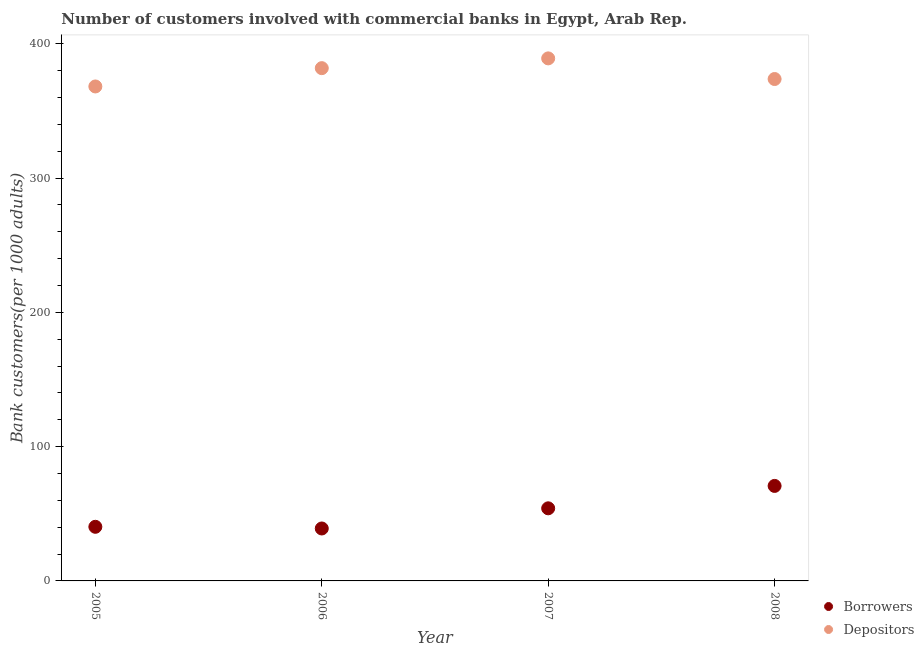How many different coloured dotlines are there?
Ensure brevity in your answer.  2. Is the number of dotlines equal to the number of legend labels?
Ensure brevity in your answer.  Yes. What is the number of borrowers in 2007?
Keep it short and to the point. 54.06. Across all years, what is the maximum number of borrowers?
Give a very brief answer. 70.74. Across all years, what is the minimum number of depositors?
Offer a very short reply. 368.19. In which year was the number of depositors maximum?
Keep it short and to the point. 2007. In which year was the number of depositors minimum?
Give a very brief answer. 2005. What is the total number of depositors in the graph?
Make the answer very short. 1512.86. What is the difference between the number of depositors in 2006 and that in 2008?
Give a very brief answer. 8.09. What is the difference between the number of depositors in 2006 and the number of borrowers in 2008?
Make the answer very short. 311.08. What is the average number of depositors per year?
Offer a terse response. 378.22. In the year 2006, what is the difference between the number of depositors and number of borrowers?
Offer a very short reply. 342.78. What is the ratio of the number of depositors in 2007 to that in 2008?
Provide a short and direct response. 1.04. Is the number of depositors in 2005 less than that in 2006?
Provide a short and direct response. Yes. Is the difference between the number of borrowers in 2005 and 2006 greater than the difference between the number of depositors in 2005 and 2006?
Your answer should be very brief. Yes. What is the difference between the highest and the second highest number of borrowers?
Your answer should be compact. 16.68. What is the difference between the highest and the lowest number of depositors?
Provide a short and direct response. 20.91. In how many years, is the number of depositors greater than the average number of depositors taken over all years?
Your response must be concise. 2. Is the sum of the number of borrowers in 2005 and 2006 greater than the maximum number of depositors across all years?
Your response must be concise. No. How many dotlines are there?
Keep it short and to the point. 2. What is the difference between two consecutive major ticks on the Y-axis?
Provide a short and direct response. 100. Are the values on the major ticks of Y-axis written in scientific E-notation?
Ensure brevity in your answer.  No. Does the graph contain grids?
Your response must be concise. No. What is the title of the graph?
Make the answer very short. Number of customers involved with commercial banks in Egypt, Arab Rep. Does "Frequency of shipment arrival" appear as one of the legend labels in the graph?
Provide a short and direct response. No. What is the label or title of the X-axis?
Your response must be concise. Year. What is the label or title of the Y-axis?
Your response must be concise. Bank customers(per 1000 adults). What is the Bank customers(per 1000 adults) in Borrowers in 2005?
Make the answer very short. 40.3. What is the Bank customers(per 1000 adults) in Depositors in 2005?
Your response must be concise. 368.19. What is the Bank customers(per 1000 adults) of Borrowers in 2006?
Ensure brevity in your answer.  39.05. What is the Bank customers(per 1000 adults) of Depositors in 2006?
Provide a short and direct response. 381.83. What is the Bank customers(per 1000 adults) of Borrowers in 2007?
Offer a very short reply. 54.06. What is the Bank customers(per 1000 adults) in Depositors in 2007?
Your response must be concise. 389.11. What is the Bank customers(per 1000 adults) in Borrowers in 2008?
Give a very brief answer. 70.74. What is the Bank customers(per 1000 adults) in Depositors in 2008?
Offer a terse response. 373.74. Across all years, what is the maximum Bank customers(per 1000 adults) of Borrowers?
Your response must be concise. 70.74. Across all years, what is the maximum Bank customers(per 1000 adults) of Depositors?
Your answer should be very brief. 389.11. Across all years, what is the minimum Bank customers(per 1000 adults) of Borrowers?
Your answer should be very brief. 39.05. Across all years, what is the minimum Bank customers(per 1000 adults) of Depositors?
Your response must be concise. 368.19. What is the total Bank customers(per 1000 adults) of Borrowers in the graph?
Keep it short and to the point. 204.15. What is the total Bank customers(per 1000 adults) in Depositors in the graph?
Offer a very short reply. 1512.86. What is the difference between the Bank customers(per 1000 adults) in Borrowers in 2005 and that in 2006?
Offer a terse response. 1.25. What is the difference between the Bank customers(per 1000 adults) in Depositors in 2005 and that in 2006?
Provide a succinct answer. -13.63. What is the difference between the Bank customers(per 1000 adults) of Borrowers in 2005 and that in 2007?
Your answer should be very brief. -13.77. What is the difference between the Bank customers(per 1000 adults) in Depositors in 2005 and that in 2007?
Make the answer very short. -20.91. What is the difference between the Bank customers(per 1000 adults) of Borrowers in 2005 and that in 2008?
Give a very brief answer. -30.45. What is the difference between the Bank customers(per 1000 adults) of Depositors in 2005 and that in 2008?
Give a very brief answer. -5.54. What is the difference between the Bank customers(per 1000 adults) in Borrowers in 2006 and that in 2007?
Keep it short and to the point. -15.02. What is the difference between the Bank customers(per 1000 adults) in Depositors in 2006 and that in 2007?
Give a very brief answer. -7.28. What is the difference between the Bank customers(per 1000 adults) of Borrowers in 2006 and that in 2008?
Provide a short and direct response. -31.69. What is the difference between the Bank customers(per 1000 adults) in Depositors in 2006 and that in 2008?
Ensure brevity in your answer.  8.09. What is the difference between the Bank customers(per 1000 adults) of Borrowers in 2007 and that in 2008?
Keep it short and to the point. -16.68. What is the difference between the Bank customers(per 1000 adults) of Depositors in 2007 and that in 2008?
Offer a terse response. 15.37. What is the difference between the Bank customers(per 1000 adults) in Borrowers in 2005 and the Bank customers(per 1000 adults) in Depositors in 2006?
Keep it short and to the point. -341.53. What is the difference between the Bank customers(per 1000 adults) in Borrowers in 2005 and the Bank customers(per 1000 adults) in Depositors in 2007?
Keep it short and to the point. -348.81. What is the difference between the Bank customers(per 1000 adults) in Borrowers in 2005 and the Bank customers(per 1000 adults) in Depositors in 2008?
Your answer should be compact. -333.44. What is the difference between the Bank customers(per 1000 adults) of Borrowers in 2006 and the Bank customers(per 1000 adults) of Depositors in 2007?
Provide a short and direct response. -350.06. What is the difference between the Bank customers(per 1000 adults) of Borrowers in 2006 and the Bank customers(per 1000 adults) of Depositors in 2008?
Your answer should be very brief. -334.69. What is the difference between the Bank customers(per 1000 adults) of Borrowers in 2007 and the Bank customers(per 1000 adults) of Depositors in 2008?
Ensure brevity in your answer.  -319.67. What is the average Bank customers(per 1000 adults) of Borrowers per year?
Give a very brief answer. 51.04. What is the average Bank customers(per 1000 adults) of Depositors per year?
Your answer should be compact. 378.22. In the year 2005, what is the difference between the Bank customers(per 1000 adults) in Borrowers and Bank customers(per 1000 adults) in Depositors?
Your answer should be very brief. -327.9. In the year 2006, what is the difference between the Bank customers(per 1000 adults) of Borrowers and Bank customers(per 1000 adults) of Depositors?
Offer a very short reply. -342.78. In the year 2007, what is the difference between the Bank customers(per 1000 adults) of Borrowers and Bank customers(per 1000 adults) of Depositors?
Provide a short and direct response. -335.04. In the year 2008, what is the difference between the Bank customers(per 1000 adults) of Borrowers and Bank customers(per 1000 adults) of Depositors?
Your answer should be compact. -302.99. What is the ratio of the Bank customers(per 1000 adults) of Borrowers in 2005 to that in 2006?
Offer a terse response. 1.03. What is the ratio of the Bank customers(per 1000 adults) in Depositors in 2005 to that in 2006?
Your answer should be very brief. 0.96. What is the ratio of the Bank customers(per 1000 adults) in Borrowers in 2005 to that in 2007?
Provide a short and direct response. 0.75. What is the ratio of the Bank customers(per 1000 adults) in Depositors in 2005 to that in 2007?
Your answer should be compact. 0.95. What is the ratio of the Bank customers(per 1000 adults) in Borrowers in 2005 to that in 2008?
Provide a succinct answer. 0.57. What is the ratio of the Bank customers(per 1000 adults) in Depositors in 2005 to that in 2008?
Offer a terse response. 0.99. What is the ratio of the Bank customers(per 1000 adults) in Borrowers in 2006 to that in 2007?
Keep it short and to the point. 0.72. What is the ratio of the Bank customers(per 1000 adults) of Depositors in 2006 to that in 2007?
Ensure brevity in your answer.  0.98. What is the ratio of the Bank customers(per 1000 adults) in Borrowers in 2006 to that in 2008?
Make the answer very short. 0.55. What is the ratio of the Bank customers(per 1000 adults) in Depositors in 2006 to that in 2008?
Make the answer very short. 1.02. What is the ratio of the Bank customers(per 1000 adults) in Borrowers in 2007 to that in 2008?
Keep it short and to the point. 0.76. What is the ratio of the Bank customers(per 1000 adults) of Depositors in 2007 to that in 2008?
Give a very brief answer. 1.04. What is the difference between the highest and the second highest Bank customers(per 1000 adults) in Borrowers?
Provide a short and direct response. 16.68. What is the difference between the highest and the second highest Bank customers(per 1000 adults) of Depositors?
Provide a succinct answer. 7.28. What is the difference between the highest and the lowest Bank customers(per 1000 adults) in Borrowers?
Your answer should be compact. 31.69. What is the difference between the highest and the lowest Bank customers(per 1000 adults) in Depositors?
Ensure brevity in your answer.  20.91. 